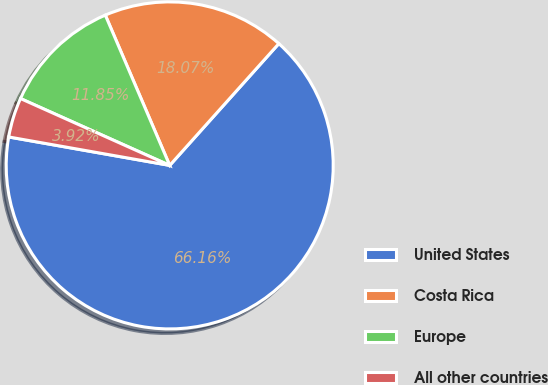Convert chart to OTSL. <chart><loc_0><loc_0><loc_500><loc_500><pie_chart><fcel>United States<fcel>Costa Rica<fcel>Europe<fcel>All other countries<nl><fcel>66.15%<fcel>18.07%<fcel>11.85%<fcel>3.92%<nl></chart> 